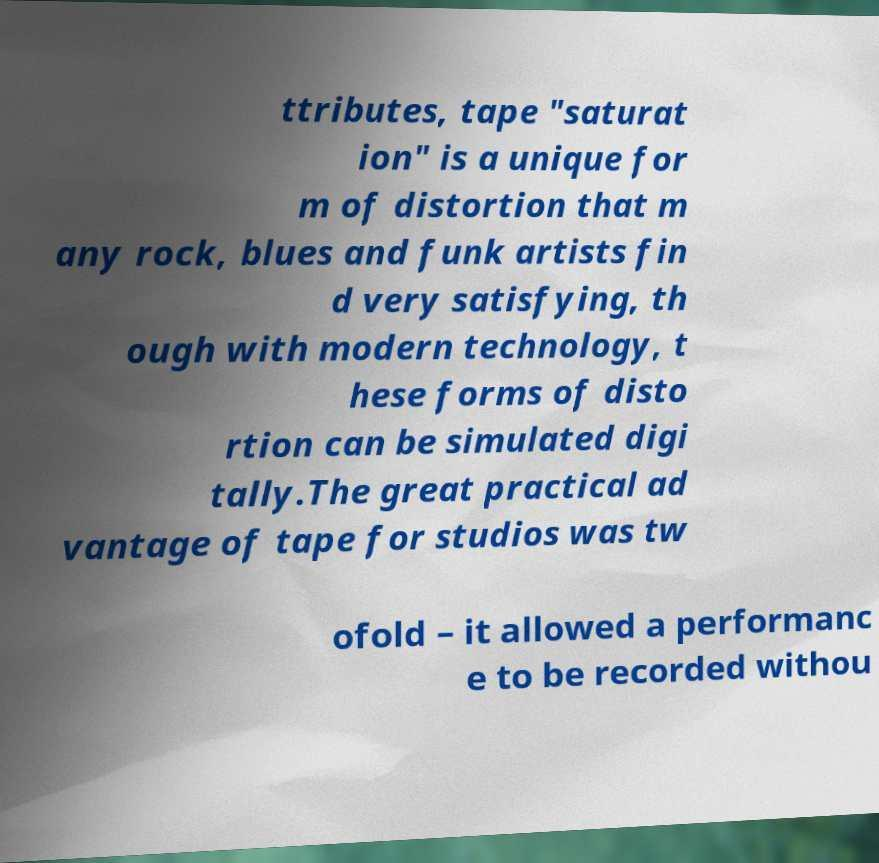Can you read and provide the text displayed in the image?This photo seems to have some interesting text. Can you extract and type it out for me? ttributes, tape "saturat ion" is a unique for m of distortion that m any rock, blues and funk artists fin d very satisfying, th ough with modern technology, t hese forms of disto rtion can be simulated digi tally.The great practical ad vantage of tape for studios was tw ofold – it allowed a performanc e to be recorded withou 